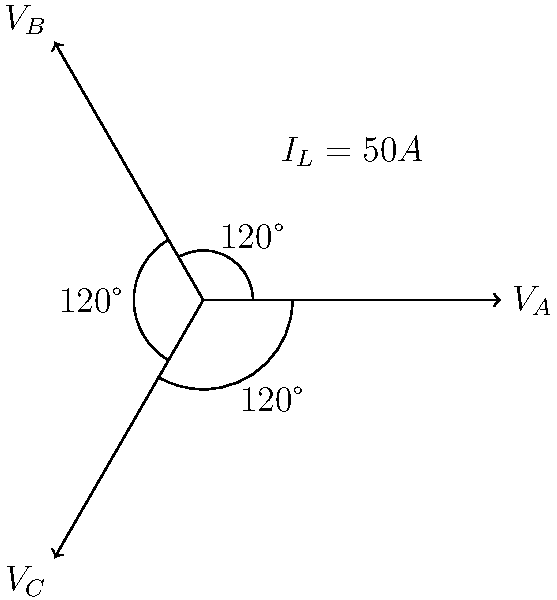As a former city council member familiar with power infrastructure, you're asked to consult on a three-phase power system upgrade. Given the phasor diagram showing a balanced three-phase system with line-to-line voltage of 480V and line current of 50A, calculate the total real power delivered by this system. Assume the power factor is 0.85 lagging. To calculate the total real power in a three-phase system, we'll follow these steps:

1) First, recall the formula for three-phase power:
   $P = \sqrt{3} \cdot V_{L-L} \cdot I_L \cdot \cos\theta$

   Where:
   $P$ is the total real power
   $V_{L-L}$ is the line-to-line voltage
   $I_L$ is the line current
   $\cos\theta$ is the power factor

2) We're given:
   $V_{L-L} = 480V$
   $I_L = 50A$
   $\cos\theta = 0.85$ (lagging)

3) Substituting these values into the formula:
   $P = \sqrt{3} \cdot 480V \cdot 50A \cdot 0.85$

4) Calculate:
   $P = 1.732 \cdot 480 \cdot 50 \cdot 0.85$
   $P = 35,332.8W$

5) Convert to kilowatts:
   $P = 35.3328kW$

Therefore, the total real power delivered by this three-phase system is approximately 35.33kW.
Answer: 35.33 kW 